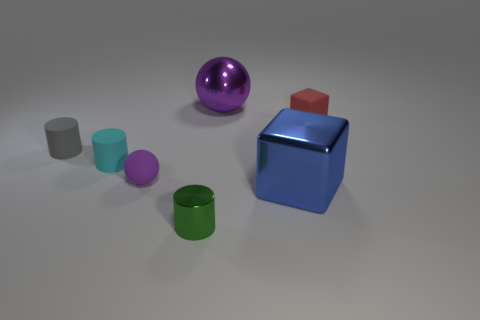Subtract all green cylinders. How many cylinders are left? 2 Subtract all cylinders. How many objects are left? 4 Add 3 gray objects. How many objects exist? 10 Subtract 0 brown cubes. How many objects are left? 7 Subtract 1 cylinders. How many cylinders are left? 2 Subtract all yellow cylinders. Subtract all red cubes. How many cylinders are left? 3 Subtract all brown balls. How many blue cylinders are left? 0 Subtract all tiny red rubber cylinders. Subtract all large objects. How many objects are left? 5 Add 5 gray matte objects. How many gray matte objects are left? 6 Add 7 big shiny spheres. How many big shiny spheres exist? 8 